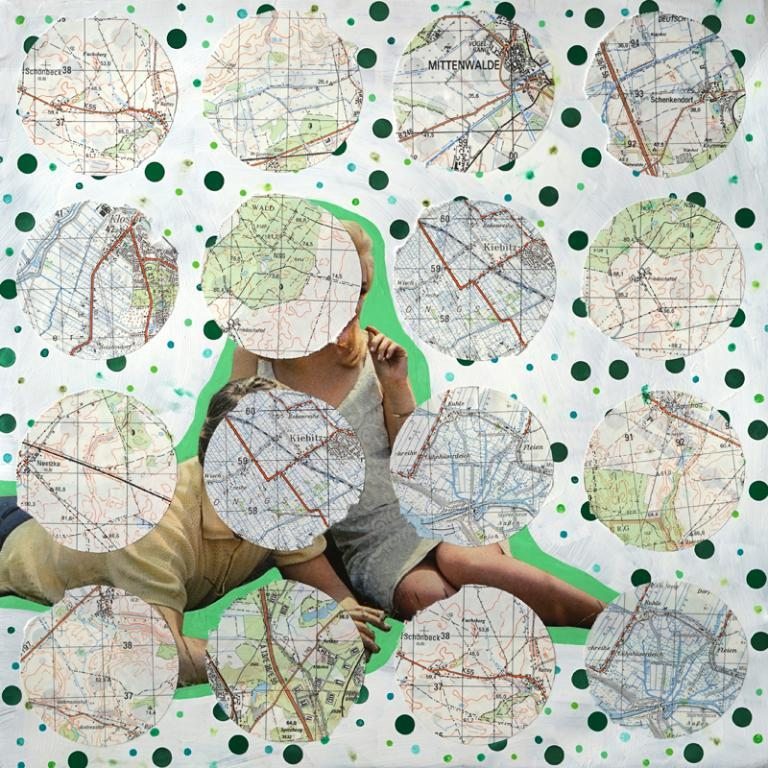Who or what is present in the image? There are people in the image. What else can be seen in the image besides the people? There are logos and text in the image. What type of invention is being demonstrated by the chicken in the image? There is no chicken present in the image, and therefore no invention can be demonstrated by a chicken. 